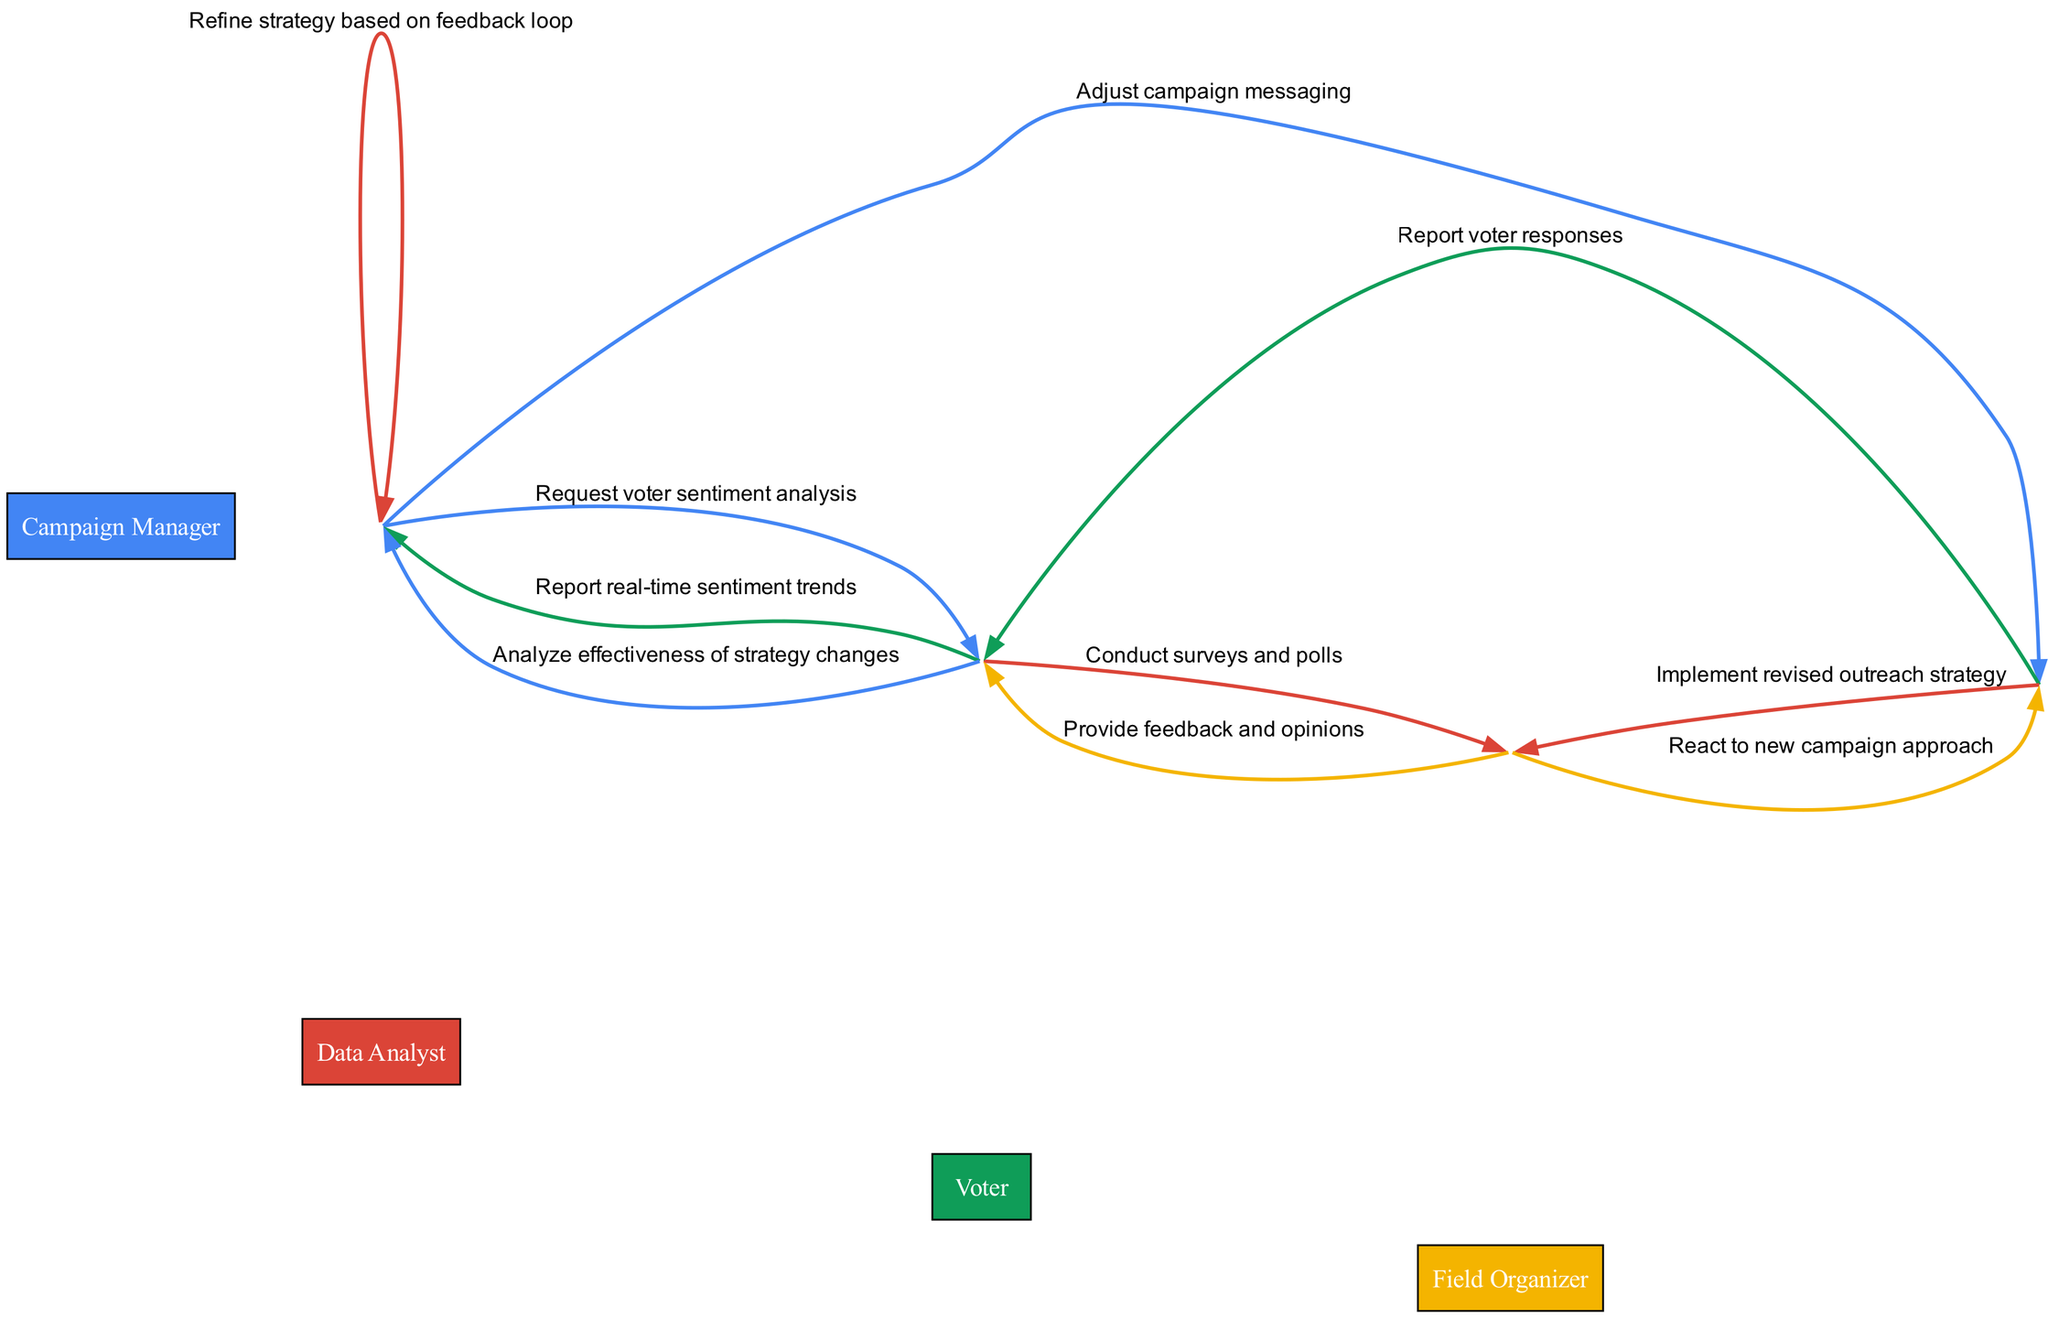What is the first action taken by the Campaign Manager? The first action taken is a request for voter sentiment analysis directed to the Data Analyst. It's the initial step that starts the sequence of activities related to understanding voter sentiment.
Answer: Request voter sentiment analysis How many actors are involved in the diagram? The diagram features four distinct actors: Campaign Manager, Data Analyst, Field Organizer, and Voter. By counting the named nodes, we determine the total number of actors.
Answer: Four What does the Field Organizer implement after receiving instructions? The Field Organizer implements a revised outreach strategy as instructed by the Campaign Manager, as per the established sequence in the diagram.
Answer: Implement revised outreach strategy What type of feedback does the Voter provide to the Data Analyst? The Voter provides feedback and opinions, which is a crucial step for the Data Analyst to analyze public sentiment accurately.
Answer: Feedback and opinions Which node receives the report of real-time sentiment trends? The Campaign Manager is the recipient of the report on real-time sentiment trends from the Data Analyst, making it an important communication in the strategy adaptation process.
Answer: Campaign Manager How many times does the Data Analyst communicate with the Campaign Manager? The Data Analyst communicates with the Campaign Manager two times in the diagram. First, when reporting real-time sentiment trends and then after analyzing the effectiveness of strategy changes.
Answer: Two What is the last action taken in the sequence? The last action in the sequence is that the Campaign Manager refines the strategy based on the feedback loop, indicating an iterative process for strategy improvement.
Answer: Refine strategy based on feedback loop What does the Field Organizer report back to the Data Analyst? The Field Organizer reports voter responses back to the Data Analyst, which is pivotal for assessing the outreach strategy's effectiveness.
Answer: Report voter responses Which actor is directly influenced by the Field Organizer's actions? The Voter is directly influenced by the Field Organizer's actions when the new campaign approach is implemented, and their reactions are solicited afterwards.
Answer: Voter 